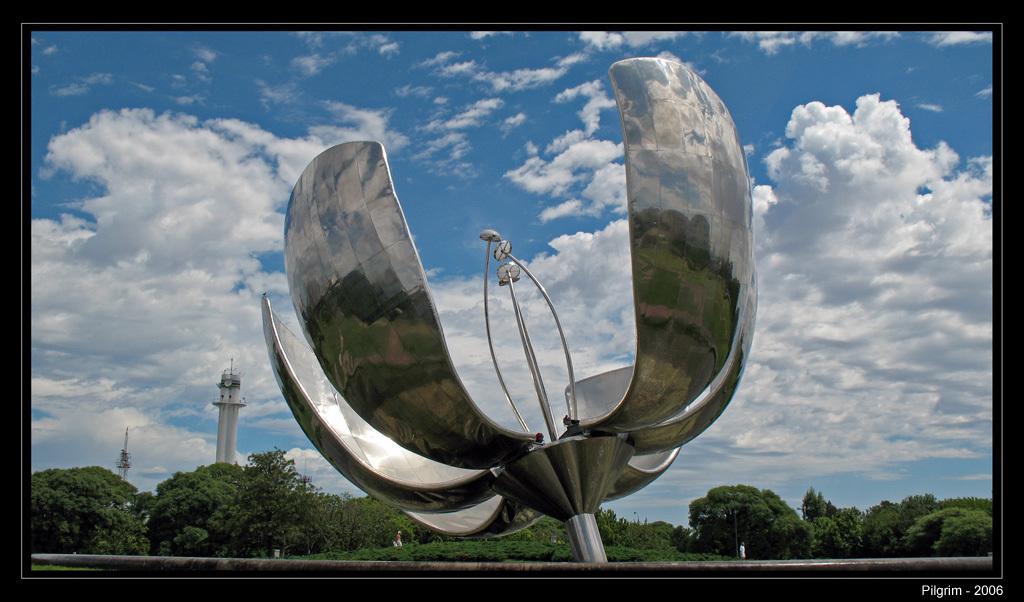Could you give a brief overview of what you see in this image? In the center of the image there is a statue. In the background we can see tower, trees, sky and cloud. 